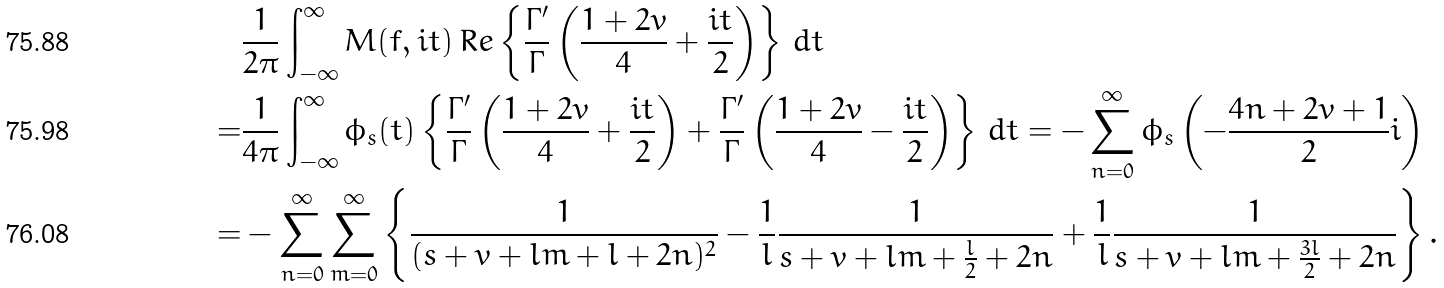Convert formula to latex. <formula><loc_0><loc_0><loc_500><loc_500>& \frac { 1 } { 2 \pi } \int _ { - \infty } ^ { \infty } M ( f , i t ) \, R e \left \{ \frac { \Gamma ^ { \prime } } { \Gamma } \left ( \frac { 1 + 2 v } { 4 } + \frac { i t } { 2 } \right ) \right \} \, d t \\ = & \frac { 1 } { 4 \pi } \int _ { - \infty } ^ { \infty } \phi _ { s } ( t ) \left \{ \frac { \Gamma ^ { \prime } } { \Gamma } \left ( \frac { 1 + 2 v } { 4 } + \frac { i t } { 2 } \right ) + \frac { \Gamma ^ { \prime } } { \Gamma } \left ( \frac { 1 + 2 v } { 4 } - \frac { i t } { 2 } \right ) \right \} \, d t = - \sum _ { n = 0 } ^ { \infty } \phi _ { s } \left ( - \frac { 4 n + 2 v + 1 } { 2 } i \right ) \\ = & - \sum _ { n = 0 } ^ { \infty } \sum _ { m = 0 } ^ { \infty } \left \{ \frac { 1 } { ( s + v + l m + l + 2 n ) ^ { 2 } } - \frac { 1 } { l } \frac { 1 } { s + v + l m + \frac { l } { 2 } + 2 n } + \frac { 1 } { l } \frac { 1 } { s + v + l m + \frac { 3 l } { 2 } + 2 n } \right \} .</formula> 